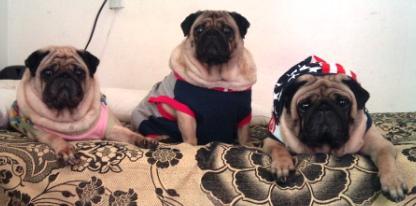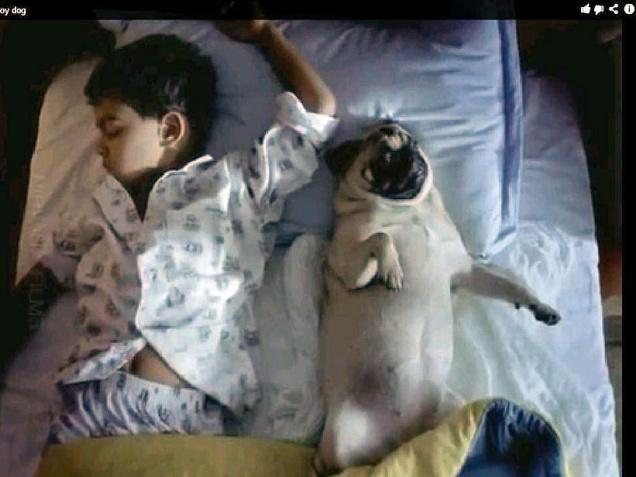The first image is the image on the left, the second image is the image on the right. Evaluate the accuracy of this statement regarding the images: "The left image contains a row of three pugs, and the right image shows one pug lying flat.". Is it true? Answer yes or no. Yes. The first image is the image on the left, the second image is the image on the right. Evaluate the accuracy of this statement regarding the images: "There are exactly four dogs in total.". Is it true? Answer yes or no. Yes. 